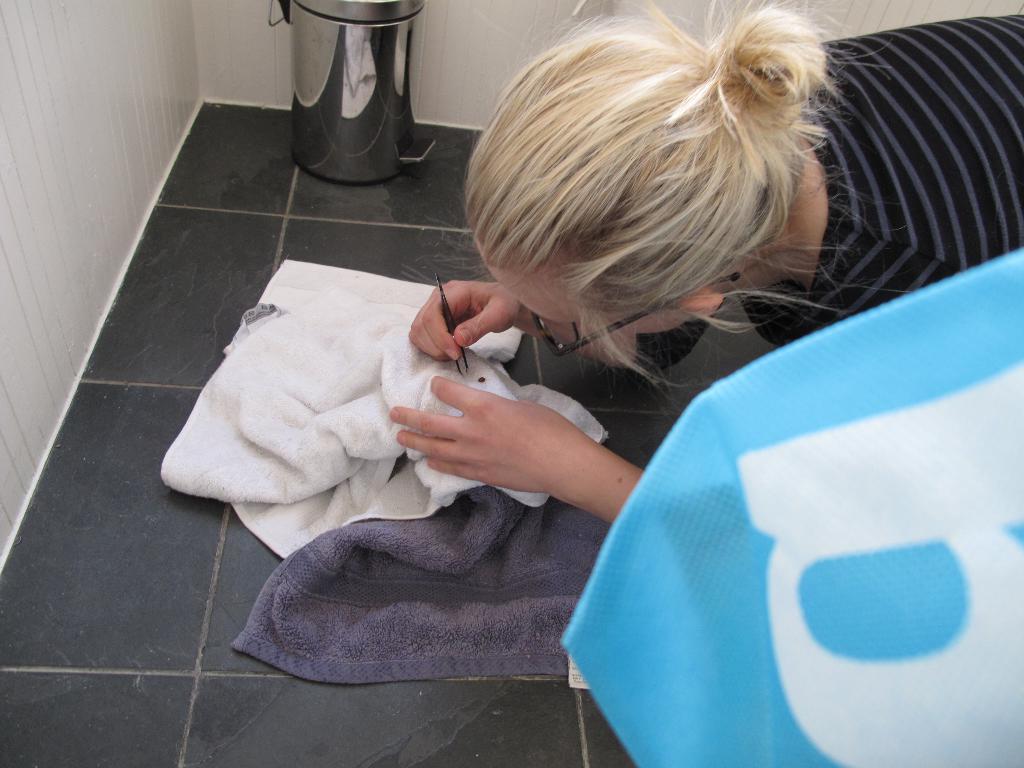What letter is thie?
Offer a very short reply. B. 